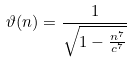Convert formula to latex. <formula><loc_0><loc_0><loc_500><loc_500>\vartheta ( n ) = \frac { 1 } { \sqrt { 1 - \frac { n ^ { 7 } } { c ^ { 7 } } } }</formula> 